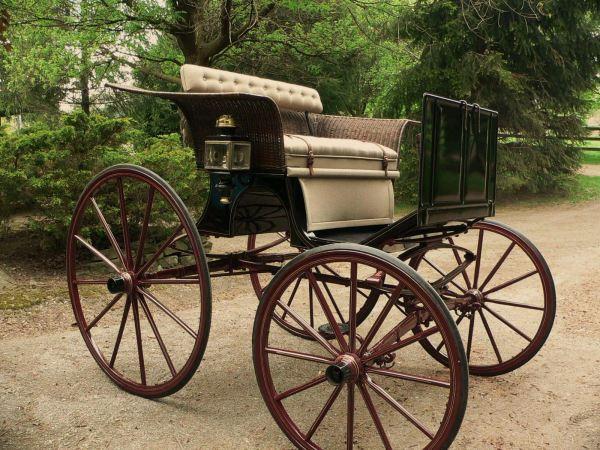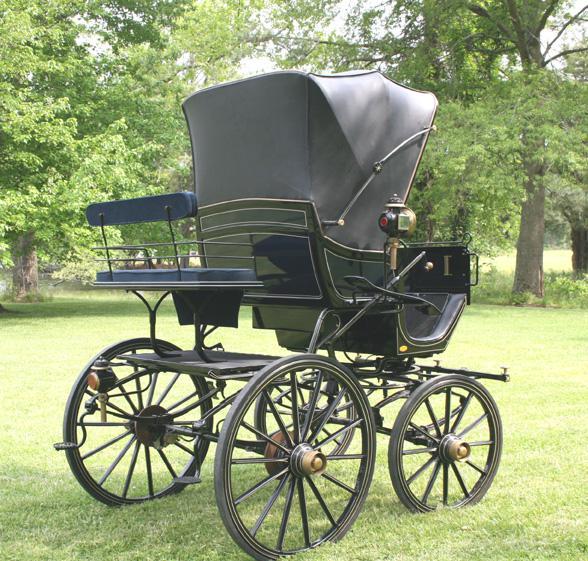The first image is the image on the left, the second image is the image on the right. Given the left and right images, does the statement "The carriage in the right image is covered." hold true? Answer yes or no. Yes. The first image is the image on the left, the second image is the image on the right. Analyze the images presented: Is the assertion "There is a total of two empty four wheel carts." valid? Answer yes or no. Yes. 